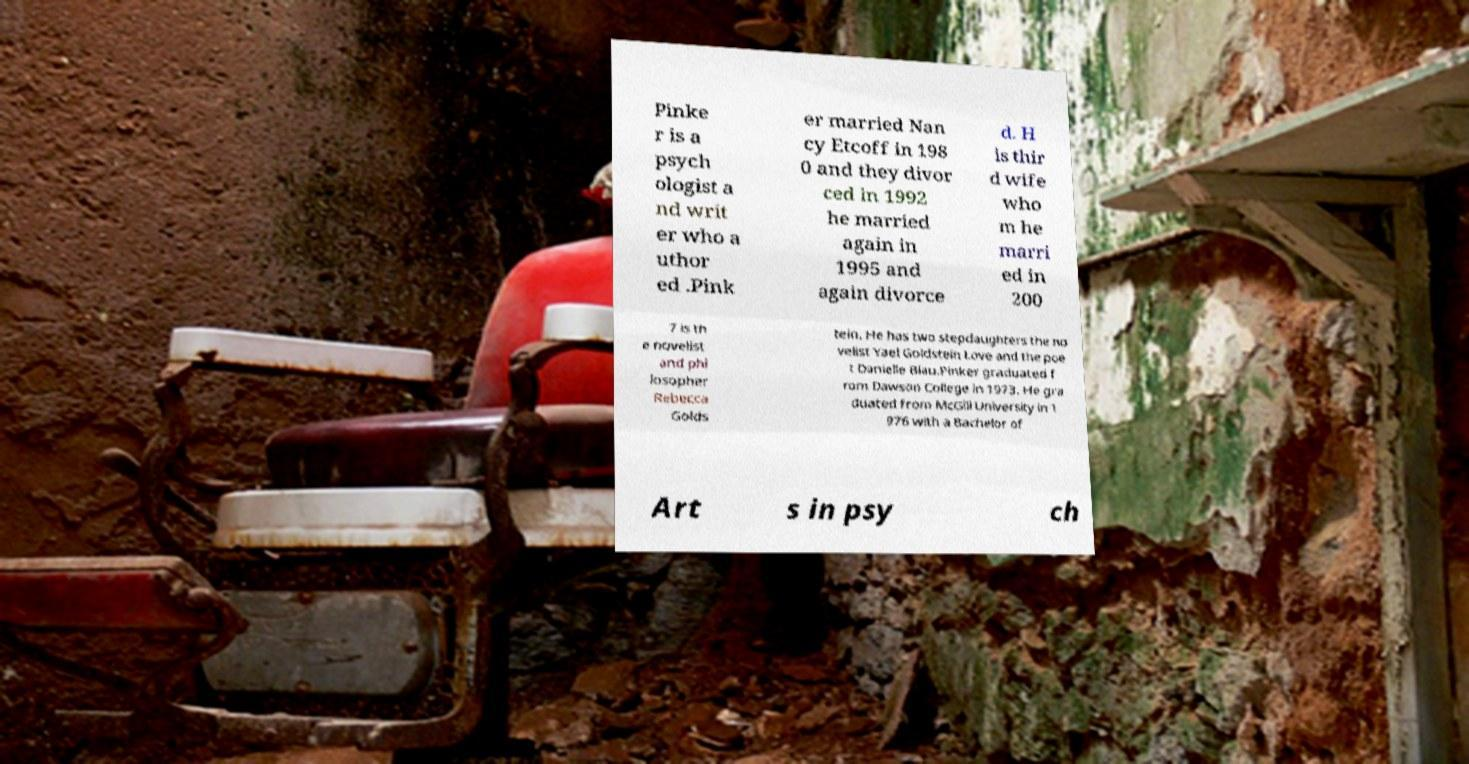Please read and relay the text visible in this image. What does it say? Pinke r is a psych ologist a nd writ er who a uthor ed .Pink er married Nan cy Etcoff in 198 0 and they divor ced in 1992 he married again in 1995 and again divorce d. H is thir d wife who m he marri ed in 200 7 is th e novelist and phi losopher Rebecca Golds tein. He has two stepdaughters the no velist Yael Goldstein Love and the poe t Danielle Blau.Pinker graduated f rom Dawson College in 1973. He gra duated from McGill University in 1 976 with a Bachelor of Art s in psy ch 